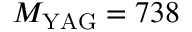<formula> <loc_0><loc_0><loc_500><loc_500>M _ { Y A G } = 7 3 8</formula> 